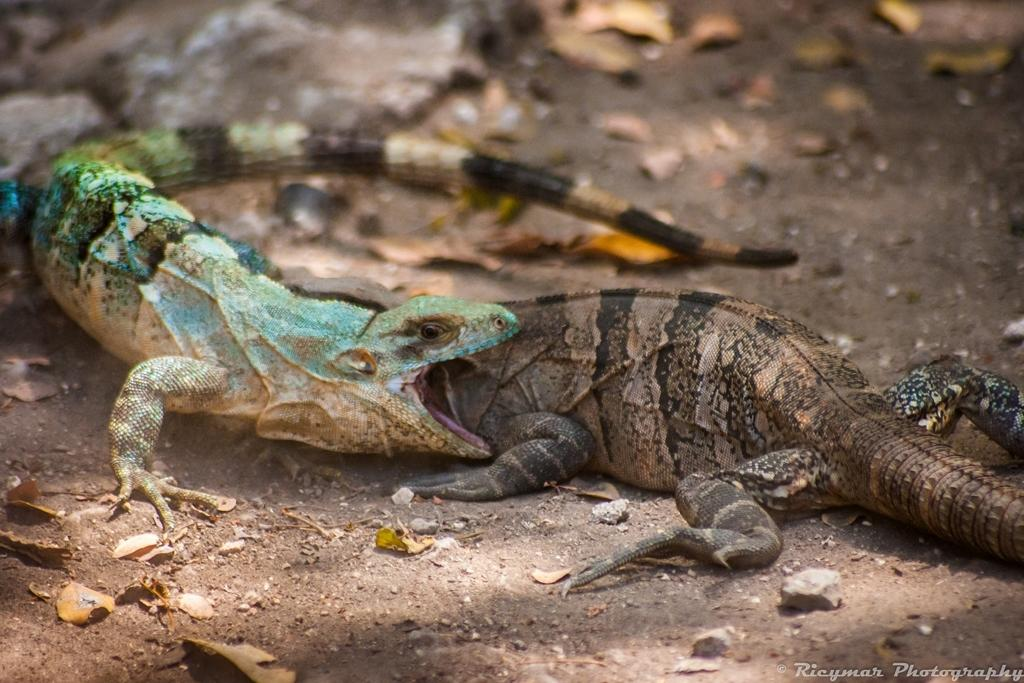How many reptiles are present in the image? There are two reptiles in the image. What colors can be seen on the reptiles? The reptiles are in green, brown, and black colors. Can you describe the background of the image? The background of the image is blurred. What type of jam is being spread on the bag in the image? There is no jam or bag present in the image; it features two reptiles with a blurred background. 